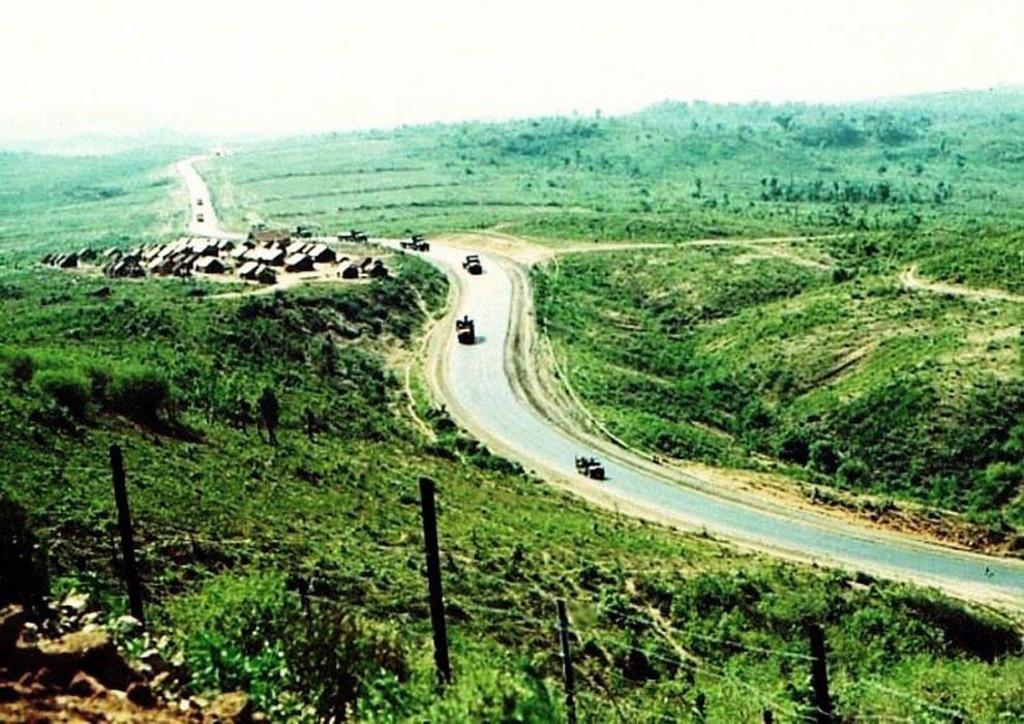What type of structure can be seen in the image? There are fencing wires in the image. What is present on the left side of the image? There are trees on the left side of the image. What is present on the right side of the image? There are trees on the right side of the image. What can be seen in the middle of the image? There are vehicles on the road in the middle of the image. Can you see a kitten playing on the street in the image? There is no kitten or street present in the image. How low are the trees in the image? The image does not provide information about the height of the trees, only that they are present on both sides. 